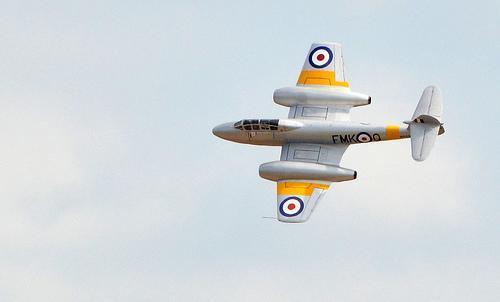How many engines does the plane have?
Give a very brief answer. 2. 